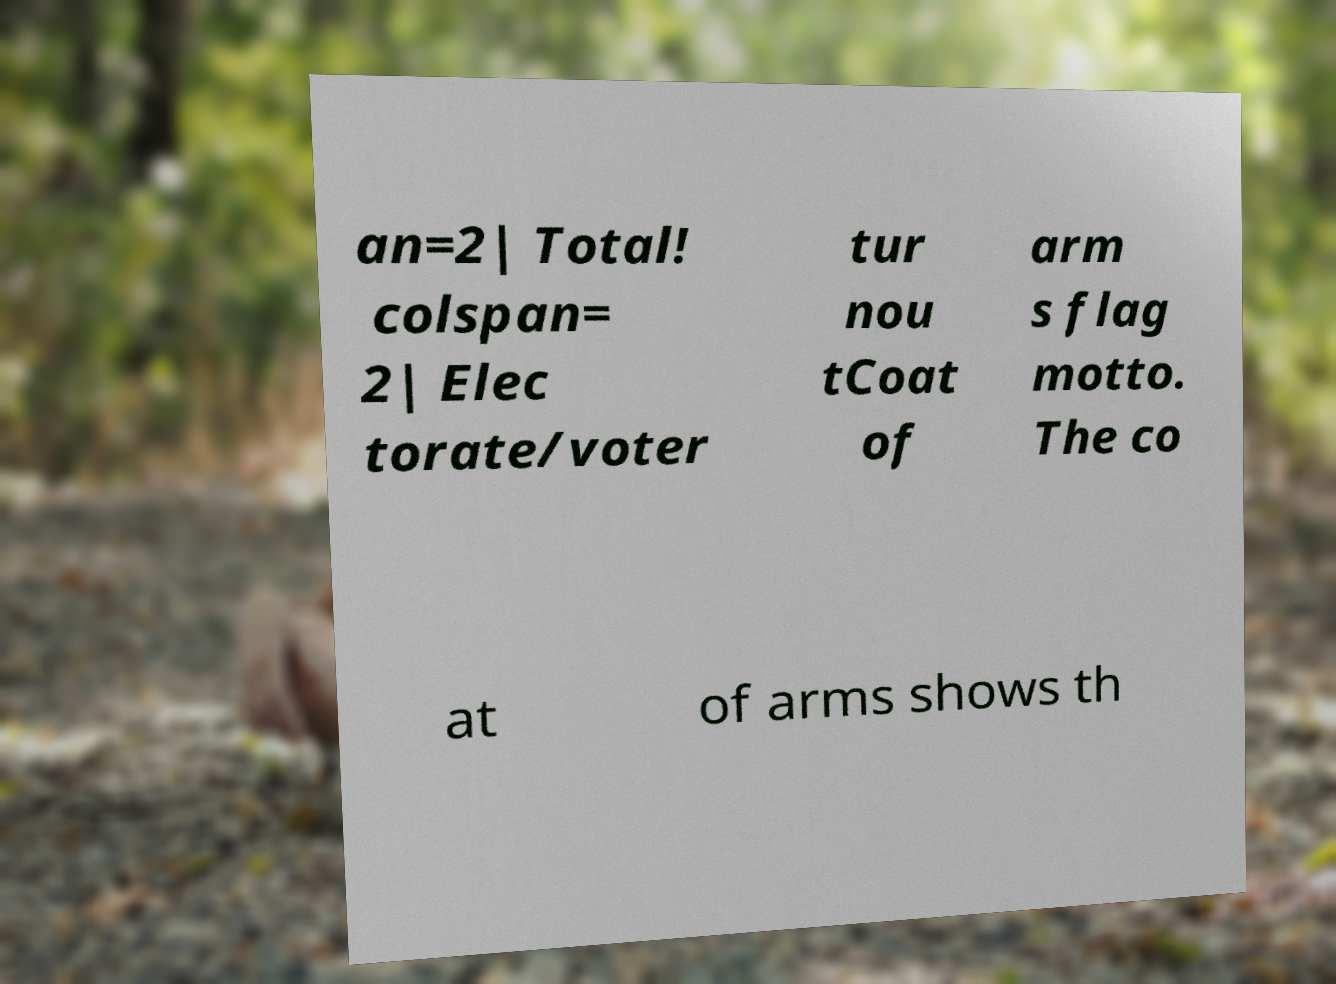Could you assist in decoding the text presented in this image and type it out clearly? an=2| Total! colspan= 2| Elec torate/voter tur nou tCoat of arm s flag motto. The co at of arms shows th 